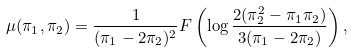Convert formula to latex. <formula><loc_0><loc_0><loc_500><loc_500>\mu ( \pi _ { 1 } , \pi _ { 2 } ) = \frac { 1 } { ( \pi _ { 1 } - 2 \pi _ { 2 } ) ^ { 2 } } F \left ( \log \frac { 2 ( \pi _ { 2 } ^ { 2 } - \pi _ { 1 } \pi _ { 2 } ) } { 3 ( \pi _ { 1 } - 2 \pi _ { 2 } ) } \right ) ,</formula> 